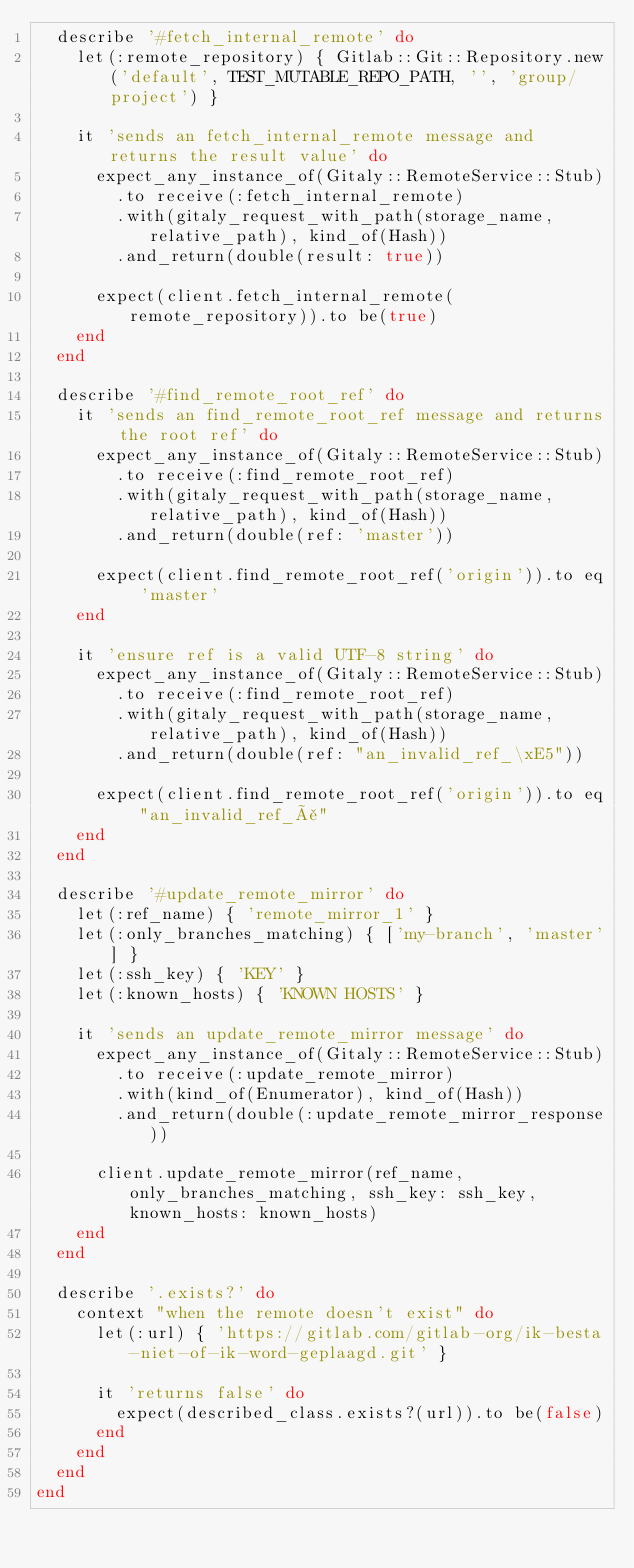Convert code to text. <code><loc_0><loc_0><loc_500><loc_500><_Ruby_>  describe '#fetch_internal_remote' do
    let(:remote_repository) { Gitlab::Git::Repository.new('default', TEST_MUTABLE_REPO_PATH, '', 'group/project') }

    it 'sends an fetch_internal_remote message and returns the result value' do
      expect_any_instance_of(Gitaly::RemoteService::Stub)
        .to receive(:fetch_internal_remote)
        .with(gitaly_request_with_path(storage_name, relative_path), kind_of(Hash))
        .and_return(double(result: true))

      expect(client.fetch_internal_remote(remote_repository)).to be(true)
    end
  end

  describe '#find_remote_root_ref' do
    it 'sends an find_remote_root_ref message and returns the root ref' do
      expect_any_instance_of(Gitaly::RemoteService::Stub)
        .to receive(:find_remote_root_ref)
        .with(gitaly_request_with_path(storage_name, relative_path), kind_of(Hash))
        .and_return(double(ref: 'master'))

      expect(client.find_remote_root_ref('origin')).to eq 'master'
    end

    it 'ensure ref is a valid UTF-8 string' do
      expect_any_instance_of(Gitaly::RemoteService::Stub)
        .to receive(:find_remote_root_ref)
        .with(gitaly_request_with_path(storage_name, relative_path), kind_of(Hash))
        .and_return(double(ref: "an_invalid_ref_\xE5"))

      expect(client.find_remote_root_ref('origin')).to eq "an_invalid_ref_å"
    end
  end

  describe '#update_remote_mirror' do
    let(:ref_name) { 'remote_mirror_1' }
    let(:only_branches_matching) { ['my-branch', 'master'] }
    let(:ssh_key) { 'KEY' }
    let(:known_hosts) { 'KNOWN HOSTS' }

    it 'sends an update_remote_mirror message' do
      expect_any_instance_of(Gitaly::RemoteService::Stub)
        .to receive(:update_remote_mirror)
        .with(kind_of(Enumerator), kind_of(Hash))
        .and_return(double(:update_remote_mirror_response))

      client.update_remote_mirror(ref_name, only_branches_matching, ssh_key: ssh_key, known_hosts: known_hosts)
    end
  end

  describe '.exists?' do
    context "when the remote doesn't exist" do
      let(:url) { 'https://gitlab.com/gitlab-org/ik-besta-niet-of-ik-word-geplaagd.git' }

      it 'returns false' do
        expect(described_class.exists?(url)).to be(false)
      end
    end
  end
end
</code> 